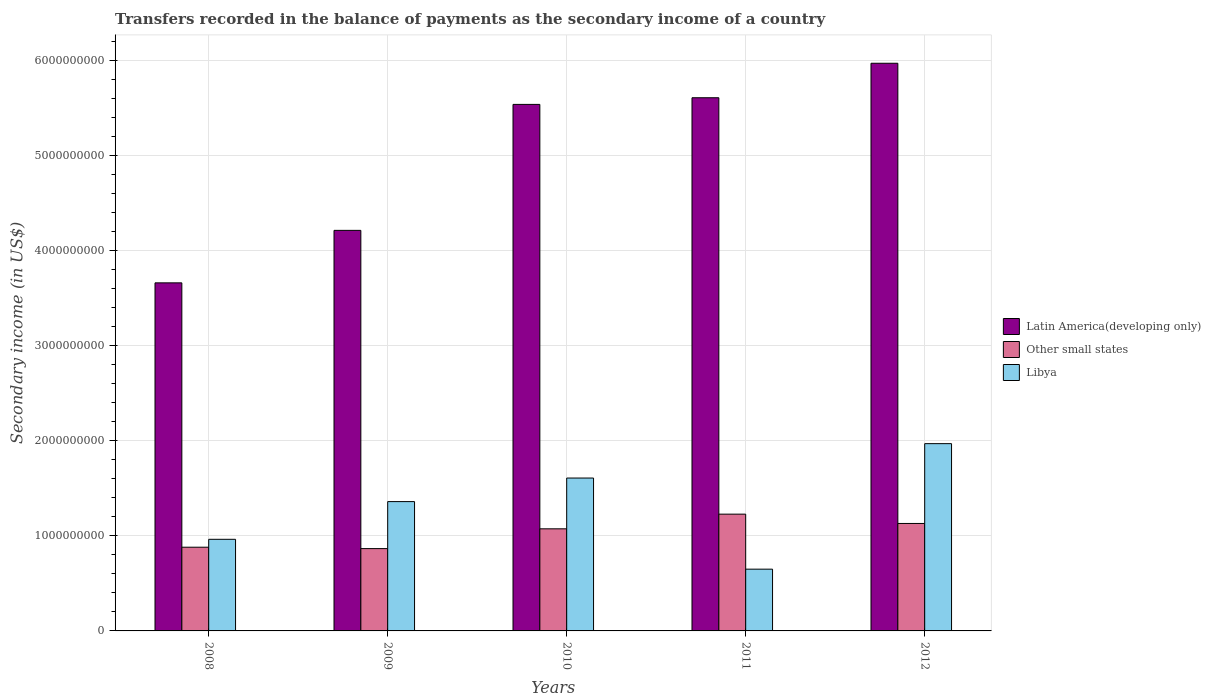How many groups of bars are there?
Your answer should be very brief. 5. In how many cases, is the number of bars for a given year not equal to the number of legend labels?
Offer a very short reply. 0. What is the secondary income of in Libya in 2010?
Your answer should be very brief. 1.61e+09. Across all years, what is the maximum secondary income of in Libya?
Your answer should be compact. 1.97e+09. Across all years, what is the minimum secondary income of in Other small states?
Offer a terse response. 8.66e+08. What is the total secondary income of in Latin America(developing only) in the graph?
Keep it short and to the point. 2.50e+1. What is the difference between the secondary income of in Other small states in 2008 and that in 2010?
Make the answer very short. -1.94e+08. What is the difference between the secondary income of in Libya in 2011 and the secondary income of in Other small states in 2009?
Offer a very short reply. -2.16e+08. What is the average secondary income of in Other small states per year?
Your answer should be very brief. 1.04e+09. In the year 2011, what is the difference between the secondary income of in Latin America(developing only) and secondary income of in Other small states?
Give a very brief answer. 4.38e+09. What is the ratio of the secondary income of in Libya in 2008 to that in 2009?
Your answer should be very brief. 0.71. Is the secondary income of in Other small states in 2008 less than that in 2009?
Give a very brief answer. No. Is the difference between the secondary income of in Latin America(developing only) in 2009 and 2011 greater than the difference between the secondary income of in Other small states in 2009 and 2011?
Your response must be concise. No. What is the difference between the highest and the second highest secondary income of in Other small states?
Give a very brief answer. 9.81e+07. What is the difference between the highest and the lowest secondary income of in Libya?
Keep it short and to the point. 1.32e+09. What does the 3rd bar from the left in 2008 represents?
Provide a succinct answer. Libya. What does the 3rd bar from the right in 2011 represents?
Offer a very short reply. Latin America(developing only). Is it the case that in every year, the sum of the secondary income of in Other small states and secondary income of in Libya is greater than the secondary income of in Latin America(developing only)?
Make the answer very short. No. How many years are there in the graph?
Offer a very short reply. 5. What is the difference between two consecutive major ticks on the Y-axis?
Make the answer very short. 1.00e+09. Does the graph contain grids?
Offer a terse response. Yes. Where does the legend appear in the graph?
Provide a short and direct response. Center right. What is the title of the graph?
Offer a terse response. Transfers recorded in the balance of payments as the secondary income of a country. Does "Luxembourg" appear as one of the legend labels in the graph?
Provide a short and direct response. No. What is the label or title of the Y-axis?
Give a very brief answer. Secondary income (in US$). What is the Secondary income (in US$) of Latin America(developing only) in 2008?
Provide a short and direct response. 3.66e+09. What is the Secondary income (in US$) in Other small states in 2008?
Provide a succinct answer. 8.81e+08. What is the Secondary income (in US$) of Libya in 2008?
Keep it short and to the point. 9.64e+08. What is the Secondary income (in US$) in Latin America(developing only) in 2009?
Give a very brief answer. 4.22e+09. What is the Secondary income (in US$) of Other small states in 2009?
Your response must be concise. 8.66e+08. What is the Secondary income (in US$) of Libya in 2009?
Make the answer very short. 1.36e+09. What is the Secondary income (in US$) of Latin America(developing only) in 2010?
Keep it short and to the point. 5.54e+09. What is the Secondary income (in US$) in Other small states in 2010?
Give a very brief answer. 1.07e+09. What is the Secondary income (in US$) in Libya in 2010?
Keep it short and to the point. 1.61e+09. What is the Secondary income (in US$) of Latin America(developing only) in 2011?
Offer a terse response. 5.61e+09. What is the Secondary income (in US$) of Other small states in 2011?
Your response must be concise. 1.23e+09. What is the Secondary income (in US$) in Libya in 2011?
Ensure brevity in your answer.  6.50e+08. What is the Secondary income (in US$) in Latin America(developing only) in 2012?
Provide a short and direct response. 5.97e+09. What is the Secondary income (in US$) in Other small states in 2012?
Provide a succinct answer. 1.13e+09. What is the Secondary income (in US$) of Libya in 2012?
Your answer should be very brief. 1.97e+09. Across all years, what is the maximum Secondary income (in US$) in Latin America(developing only)?
Your response must be concise. 5.97e+09. Across all years, what is the maximum Secondary income (in US$) of Other small states?
Provide a succinct answer. 1.23e+09. Across all years, what is the maximum Secondary income (in US$) of Libya?
Provide a short and direct response. 1.97e+09. Across all years, what is the minimum Secondary income (in US$) in Latin America(developing only)?
Offer a terse response. 3.66e+09. Across all years, what is the minimum Secondary income (in US$) of Other small states?
Offer a terse response. 8.66e+08. Across all years, what is the minimum Secondary income (in US$) of Libya?
Offer a terse response. 6.50e+08. What is the total Secondary income (in US$) in Latin America(developing only) in the graph?
Provide a short and direct response. 2.50e+1. What is the total Secondary income (in US$) in Other small states in the graph?
Offer a very short reply. 5.18e+09. What is the total Secondary income (in US$) in Libya in the graph?
Give a very brief answer. 6.56e+09. What is the difference between the Secondary income (in US$) of Latin America(developing only) in 2008 and that in 2009?
Keep it short and to the point. -5.52e+08. What is the difference between the Secondary income (in US$) of Other small states in 2008 and that in 2009?
Keep it short and to the point. 1.46e+07. What is the difference between the Secondary income (in US$) of Libya in 2008 and that in 2009?
Your response must be concise. -3.97e+08. What is the difference between the Secondary income (in US$) of Latin America(developing only) in 2008 and that in 2010?
Offer a very short reply. -1.88e+09. What is the difference between the Secondary income (in US$) of Other small states in 2008 and that in 2010?
Offer a very short reply. -1.94e+08. What is the difference between the Secondary income (in US$) of Libya in 2008 and that in 2010?
Give a very brief answer. -6.45e+08. What is the difference between the Secondary income (in US$) in Latin America(developing only) in 2008 and that in 2011?
Your answer should be very brief. -1.95e+09. What is the difference between the Secondary income (in US$) of Other small states in 2008 and that in 2011?
Give a very brief answer. -3.48e+08. What is the difference between the Secondary income (in US$) of Libya in 2008 and that in 2011?
Your answer should be compact. 3.14e+08. What is the difference between the Secondary income (in US$) in Latin America(developing only) in 2008 and that in 2012?
Give a very brief answer. -2.31e+09. What is the difference between the Secondary income (in US$) in Other small states in 2008 and that in 2012?
Your answer should be compact. -2.50e+08. What is the difference between the Secondary income (in US$) in Libya in 2008 and that in 2012?
Make the answer very short. -1.01e+09. What is the difference between the Secondary income (in US$) of Latin America(developing only) in 2009 and that in 2010?
Provide a succinct answer. -1.33e+09. What is the difference between the Secondary income (in US$) in Other small states in 2009 and that in 2010?
Offer a terse response. -2.08e+08. What is the difference between the Secondary income (in US$) in Libya in 2009 and that in 2010?
Provide a succinct answer. -2.48e+08. What is the difference between the Secondary income (in US$) in Latin America(developing only) in 2009 and that in 2011?
Offer a very short reply. -1.40e+09. What is the difference between the Secondary income (in US$) in Other small states in 2009 and that in 2011?
Your answer should be very brief. -3.63e+08. What is the difference between the Secondary income (in US$) in Libya in 2009 and that in 2011?
Keep it short and to the point. 7.11e+08. What is the difference between the Secondary income (in US$) of Latin America(developing only) in 2009 and that in 2012?
Give a very brief answer. -1.76e+09. What is the difference between the Secondary income (in US$) in Other small states in 2009 and that in 2012?
Offer a terse response. -2.64e+08. What is the difference between the Secondary income (in US$) in Libya in 2009 and that in 2012?
Your answer should be compact. -6.10e+08. What is the difference between the Secondary income (in US$) in Latin America(developing only) in 2010 and that in 2011?
Keep it short and to the point. -7.01e+07. What is the difference between the Secondary income (in US$) of Other small states in 2010 and that in 2011?
Keep it short and to the point. -1.54e+08. What is the difference between the Secondary income (in US$) in Libya in 2010 and that in 2011?
Keep it short and to the point. 9.59e+08. What is the difference between the Secondary income (in US$) in Latin America(developing only) in 2010 and that in 2012?
Your answer should be compact. -4.33e+08. What is the difference between the Secondary income (in US$) of Other small states in 2010 and that in 2012?
Your answer should be compact. -5.64e+07. What is the difference between the Secondary income (in US$) in Libya in 2010 and that in 2012?
Ensure brevity in your answer.  -3.62e+08. What is the difference between the Secondary income (in US$) in Latin America(developing only) in 2011 and that in 2012?
Offer a very short reply. -3.63e+08. What is the difference between the Secondary income (in US$) of Other small states in 2011 and that in 2012?
Your answer should be very brief. 9.81e+07. What is the difference between the Secondary income (in US$) in Libya in 2011 and that in 2012?
Make the answer very short. -1.32e+09. What is the difference between the Secondary income (in US$) in Latin America(developing only) in 2008 and the Secondary income (in US$) in Other small states in 2009?
Your answer should be compact. 2.80e+09. What is the difference between the Secondary income (in US$) of Latin America(developing only) in 2008 and the Secondary income (in US$) of Libya in 2009?
Provide a short and direct response. 2.30e+09. What is the difference between the Secondary income (in US$) in Other small states in 2008 and the Secondary income (in US$) in Libya in 2009?
Provide a succinct answer. -4.80e+08. What is the difference between the Secondary income (in US$) in Latin America(developing only) in 2008 and the Secondary income (in US$) in Other small states in 2010?
Give a very brief answer. 2.59e+09. What is the difference between the Secondary income (in US$) of Latin America(developing only) in 2008 and the Secondary income (in US$) of Libya in 2010?
Provide a short and direct response. 2.05e+09. What is the difference between the Secondary income (in US$) of Other small states in 2008 and the Secondary income (in US$) of Libya in 2010?
Provide a short and direct response. -7.28e+08. What is the difference between the Secondary income (in US$) in Latin America(developing only) in 2008 and the Secondary income (in US$) in Other small states in 2011?
Provide a short and direct response. 2.43e+09. What is the difference between the Secondary income (in US$) of Latin America(developing only) in 2008 and the Secondary income (in US$) of Libya in 2011?
Offer a very short reply. 3.01e+09. What is the difference between the Secondary income (in US$) in Other small states in 2008 and the Secondary income (in US$) in Libya in 2011?
Ensure brevity in your answer.  2.31e+08. What is the difference between the Secondary income (in US$) in Latin America(developing only) in 2008 and the Secondary income (in US$) in Other small states in 2012?
Your answer should be very brief. 2.53e+09. What is the difference between the Secondary income (in US$) of Latin America(developing only) in 2008 and the Secondary income (in US$) of Libya in 2012?
Your answer should be compact. 1.69e+09. What is the difference between the Secondary income (in US$) in Other small states in 2008 and the Secondary income (in US$) in Libya in 2012?
Keep it short and to the point. -1.09e+09. What is the difference between the Secondary income (in US$) of Latin America(developing only) in 2009 and the Secondary income (in US$) of Other small states in 2010?
Offer a very short reply. 3.14e+09. What is the difference between the Secondary income (in US$) of Latin America(developing only) in 2009 and the Secondary income (in US$) of Libya in 2010?
Ensure brevity in your answer.  2.61e+09. What is the difference between the Secondary income (in US$) of Other small states in 2009 and the Secondary income (in US$) of Libya in 2010?
Your response must be concise. -7.43e+08. What is the difference between the Secondary income (in US$) of Latin America(developing only) in 2009 and the Secondary income (in US$) of Other small states in 2011?
Offer a terse response. 2.99e+09. What is the difference between the Secondary income (in US$) in Latin America(developing only) in 2009 and the Secondary income (in US$) in Libya in 2011?
Provide a short and direct response. 3.57e+09. What is the difference between the Secondary income (in US$) in Other small states in 2009 and the Secondary income (in US$) in Libya in 2011?
Your answer should be compact. 2.16e+08. What is the difference between the Secondary income (in US$) in Latin America(developing only) in 2009 and the Secondary income (in US$) in Other small states in 2012?
Provide a short and direct response. 3.08e+09. What is the difference between the Secondary income (in US$) of Latin America(developing only) in 2009 and the Secondary income (in US$) of Libya in 2012?
Your response must be concise. 2.24e+09. What is the difference between the Secondary income (in US$) of Other small states in 2009 and the Secondary income (in US$) of Libya in 2012?
Your answer should be very brief. -1.10e+09. What is the difference between the Secondary income (in US$) in Latin America(developing only) in 2010 and the Secondary income (in US$) in Other small states in 2011?
Provide a short and direct response. 4.31e+09. What is the difference between the Secondary income (in US$) of Latin America(developing only) in 2010 and the Secondary income (in US$) of Libya in 2011?
Ensure brevity in your answer.  4.89e+09. What is the difference between the Secondary income (in US$) of Other small states in 2010 and the Secondary income (in US$) of Libya in 2011?
Make the answer very short. 4.25e+08. What is the difference between the Secondary income (in US$) of Latin America(developing only) in 2010 and the Secondary income (in US$) of Other small states in 2012?
Keep it short and to the point. 4.41e+09. What is the difference between the Secondary income (in US$) of Latin America(developing only) in 2010 and the Secondary income (in US$) of Libya in 2012?
Your response must be concise. 3.57e+09. What is the difference between the Secondary income (in US$) of Other small states in 2010 and the Secondary income (in US$) of Libya in 2012?
Make the answer very short. -8.96e+08. What is the difference between the Secondary income (in US$) in Latin America(developing only) in 2011 and the Secondary income (in US$) in Other small states in 2012?
Offer a terse response. 4.48e+09. What is the difference between the Secondary income (in US$) of Latin America(developing only) in 2011 and the Secondary income (in US$) of Libya in 2012?
Your answer should be very brief. 3.64e+09. What is the difference between the Secondary income (in US$) of Other small states in 2011 and the Secondary income (in US$) of Libya in 2012?
Make the answer very short. -7.42e+08. What is the average Secondary income (in US$) in Latin America(developing only) per year?
Keep it short and to the point. 5.00e+09. What is the average Secondary income (in US$) in Other small states per year?
Your answer should be compact. 1.04e+09. What is the average Secondary income (in US$) of Libya per year?
Make the answer very short. 1.31e+09. In the year 2008, what is the difference between the Secondary income (in US$) of Latin America(developing only) and Secondary income (in US$) of Other small states?
Your answer should be very brief. 2.78e+09. In the year 2008, what is the difference between the Secondary income (in US$) of Latin America(developing only) and Secondary income (in US$) of Libya?
Your response must be concise. 2.70e+09. In the year 2008, what is the difference between the Secondary income (in US$) in Other small states and Secondary income (in US$) in Libya?
Offer a very short reply. -8.31e+07. In the year 2009, what is the difference between the Secondary income (in US$) of Latin America(developing only) and Secondary income (in US$) of Other small states?
Make the answer very short. 3.35e+09. In the year 2009, what is the difference between the Secondary income (in US$) of Latin America(developing only) and Secondary income (in US$) of Libya?
Your answer should be compact. 2.85e+09. In the year 2009, what is the difference between the Secondary income (in US$) of Other small states and Secondary income (in US$) of Libya?
Provide a succinct answer. -4.95e+08. In the year 2010, what is the difference between the Secondary income (in US$) in Latin America(developing only) and Secondary income (in US$) in Other small states?
Ensure brevity in your answer.  4.47e+09. In the year 2010, what is the difference between the Secondary income (in US$) of Latin America(developing only) and Secondary income (in US$) of Libya?
Keep it short and to the point. 3.93e+09. In the year 2010, what is the difference between the Secondary income (in US$) of Other small states and Secondary income (in US$) of Libya?
Give a very brief answer. -5.34e+08. In the year 2011, what is the difference between the Secondary income (in US$) in Latin America(developing only) and Secondary income (in US$) in Other small states?
Your answer should be very brief. 4.38e+09. In the year 2011, what is the difference between the Secondary income (in US$) in Latin America(developing only) and Secondary income (in US$) in Libya?
Provide a succinct answer. 4.96e+09. In the year 2011, what is the difference between the Secondary income (in US$) of Other small states and Secondary income (in US$) of Libya?
Offer a terse response. 5.79e+08. In the year 2012, what is the difference between the Secondary income (in US$) of Latin America(developing only) and Secondary income (in US$) of Other small states?
Your answer should be very brief. 4.84e+09. In the year 2012, what is the difference between the Secondary income (in US$) in Latin America(developing only) and Secondary income (in US$) in Libya?
Your response must be concise. 4.00e+09. In the year 2012, what is the difference between the Secondary income (in US$) in Other small states and Secondary income (in US$) in Libya?
Make the answer very short. -8.40e+08. What is the ratio of the Secondary income (in US$) in Latin America(developing only) in 2008 to that in 2009?
Provide a succinct answer. 0.87. What is the ratio of the Secondary income (in US$) of Other small states in 2008 to that in 2009?
Make the answer very short. 1.02. What is the ratio of the Secondary income (in US$) in Libya in 2008 to that in 2009?
Give a very brief answer. 0.71. What is the ratio of the Secondary income (in US$) of Latin America(developing only) in 2008 to that in 2010?
Make the answer very short. 0.66. What is the ratio of the Secondary income (in US$) of Other small states in 2008 to that in 2010?
Provide a short and direct response. 0.82. What is the ratio of the Secondary income (in US$) in Libya in 2008 to that in 2010?
Give a very brief answer. 0.6. What is the ratio of the Secondary income (in US$) of Latin America(developing only) in 2008 to that in 2011?
Make the answer very short. 0.65. What is the ratio of the Secondary income (in US$) of Other small states in 2008 to that in 2011?
Offer a terse response. 0.72. What is the ratio of the Secondary income (in US$) of Libya in 2008 to that in 2011?
Keep it short and to the point. 1.48. What is the ratio of the Secondary income (in US$) in Latin America(developing only) in 2008 to that in 2012?
Make the answer very short. 0.61. What is the ratio of the Secondary income (in US$) in Other small states in 2008 to that in 2012?
Offer a terse response. 0.78. What is the ratio of the Secondary income (in US$) in Libya in 2008 to that in 2012?
Ensure brevity in your answer.  0.49. What is the ratio of the Secondary income (in US$) in Latin America(developing only) in 2009 to that in 2010?
Keep it short and to the point. 0.76. What is the ratio of the Secondary income (in US$) of Other small states in 2009 to that in 2010?
Give a very brief answer. 0.81. What is the ratio of the Secondary income (in US$) of Libya in 2009 to that in 2010?
Your answer should be compact. 0.85. What is the ratio of the Secondary income (in US$) in Latin America(developing only) in 2009 to that in 2011?
Provide a succinct answer. 0.75. What is the ratio of the Secondary income (in US$) in Other small states in 2009 to that in 2011?
Provide a short and direct response. 0.7. What is the ratio of the Secondary income (in US$) in Libya in 2009 to that in 2011?
Keep it short and to the point. 2.09. What is the ratio of the Secondary income (in US$) in Latin America(developing only) in 2009 to that in 2012?
Offer a terse response. 0.71. What is the ratio of the Secondary income (in US$) in Other small states in 2009 to that in 2012?
Your answer should be compact. 0.77. What is the ratio of the Secondary income (in US$) in Libya in 2009 to that in 2012?
Provide a short and direct response. 0.69. What is the ratio of the Secondary income (in US$) in Latin America(developing only) in 2010 to that in 2011?
Ensure brevity in your answer.  0.99. What is the ratio of the Secondary income (in US$) of Other small states in 2010 to that in 2011?
Your answer should be very brief. 0.87. What is the ratio of the Secondary income (in US$) in Libya in 2010 to that in 2011?
Provide a succinct answer. 2.48. What is the ratio of the Secondary income (in US$) of Latin America(developing only) in 2010 to that in 2012?
Your answer should be compact. 0.93. What is the ratio of the Secondary income (in US$) in Other small states in 2010 to that in 2012?
Keep it short and to the point. 0.95. What is the ratio of the Secondary income (in US$) of Libya in 2010 to that in 2012?
Provide a short and direct response. 0.82. What is the ratio of the Secondary income (in US$) in Latin America(developing only) in 2011 to that in 2012?
Give a very brief answer. 0.94. What is the ratio of the Secondary income (in US$) of Other small states in 2011 to that in 2012?
Your answer should be very brief. 1.09. What is the ratio of the Secondary income (in US$) in Libya in 2011 to that in 2012?
Offer a very short reply. 0.33. What is the difference between the highest and the second highest Secondary income (in US$) of Latin America(developing only)?
Ensure brevity in your answer.  3.63e+08. What is the difference between the highest and the second highest Secondary income (in US$) of Other small states?
Keep it short and to the point. 9.81e+07. What is the difference between the highest and the second highest Secondary income (in US$) of Libya?
Make the answer very short. 3.62e+08. What is the difference between the highest and the lowest Secondary income (in US$) in Latin America(developing only)?
Provide a succinct answer. 2.31e+09. What is the difference between the highest and the lowest Secondary income (in US$) in Other small states?
Make the answer very short. 3.63e+08. What is the difference between the highest and the lowest Secondary income (in US$) of Libya?
Keep it short and to the point. 1.32e+09. 